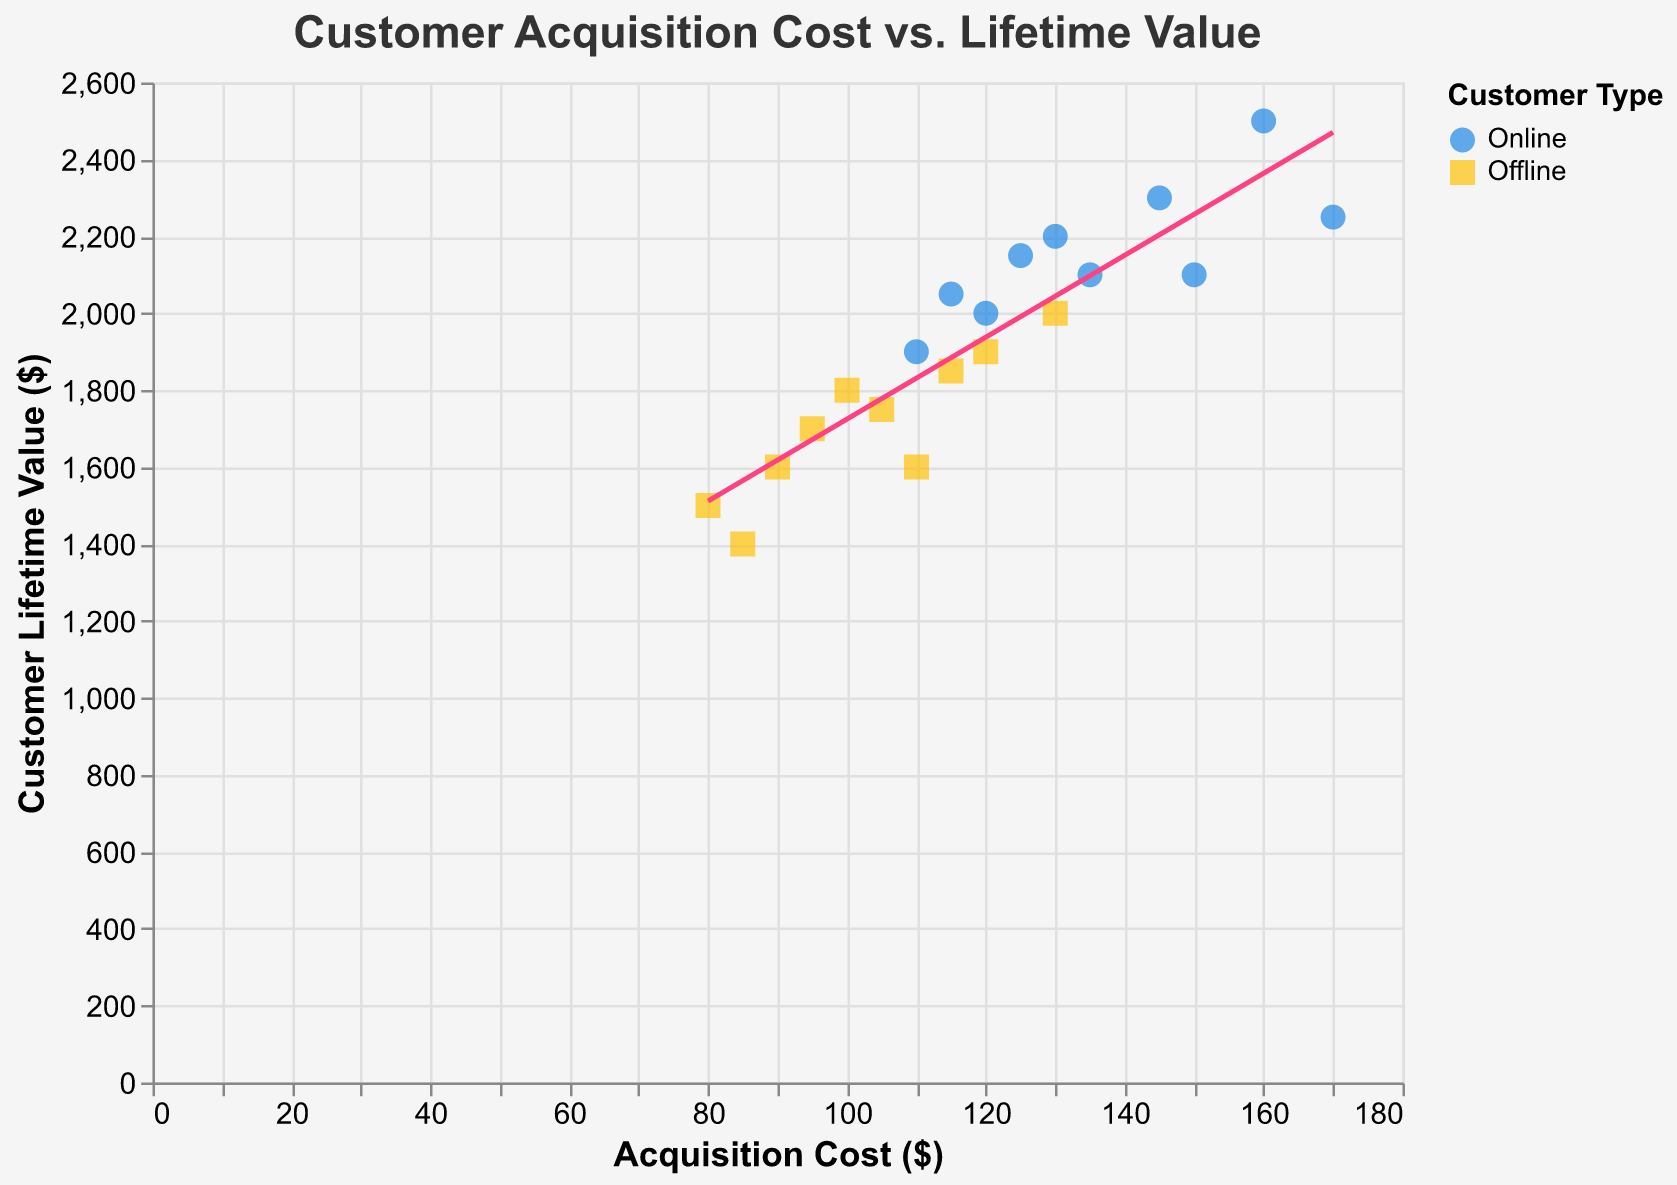What is the title of the chart? The title of the chart is written at the top center and provides a summary of what the chart represents. In this case, the title is "Customer Acquisition Cost vs. Lifetime Value."
Answer: Customer Acquisition Cost vs. Lifetime Value How many data points are there for the online gaming segment? The data points for each segment can be identified by the shape and color in the scatter plot. For the online gaming segment, blue circles represent the data points. By counting them, we find there are 10 data points.
Answer: 10 What is the axis label for the x-axis? The axis label for the x-axis is shown at the bottom of the chart and indicates what the x-axis represents, which is "Acquisition Cost ($)" in this figure.
Answer: Acquisition Cost ($) Which segment has a higher overall Customer Lifetime Value? To compare the Customer Lifetime Value between segments, observe the y-axis values. The online segment (blue circles) has higher overall values compared to the offline segment (yellow squares).
Answer: Online What is the average acquisition cost for the offline gaming segment? Add the acquisition costs for the offline segment and divide by the number of data points: (80 + 90 + 85 + 95 + 100 + 105 + 115 + 110 + 120 + 130) / 10 = 103
Answer: 103 Between online and offline segments, which has a wider range of acquisition costs? To determine the range, subtract the smallest acquisition cost from the largest for each segment. Online: 170 - 110 = 60; Offline: 130 - 80 = 50. The online segment has a wider range.
Answer: Online Is there a noticeable trend between acquisition cost and customer lifetime value? The trend line in the scatter plot helps identify if there is a trend. The chart shows a positive slope, suggesting that as acquisition cost increases, customer lifetime value also increases.
Answer: Yes By looking at the trend line, would increasing acquisition costs lead to a higher or lower customer lifetime value? The trend line indicates a positive correlation: higher acquisition costs are associated with higher customer lifetime value.
Answer: Higher Which segment has the highest individual Customer Lifetime Value? Identify the highest y-axis value among all data points and the corresponding segment. The online segment has the highest individual Customer Lifetime Value of 2500.
Answer: Online What color represents the offline gaming segment in the scatter plot? The color representing the offline gaming segment is found in the legend. It is yellow in the scatter plot.
Answer: Yellow 